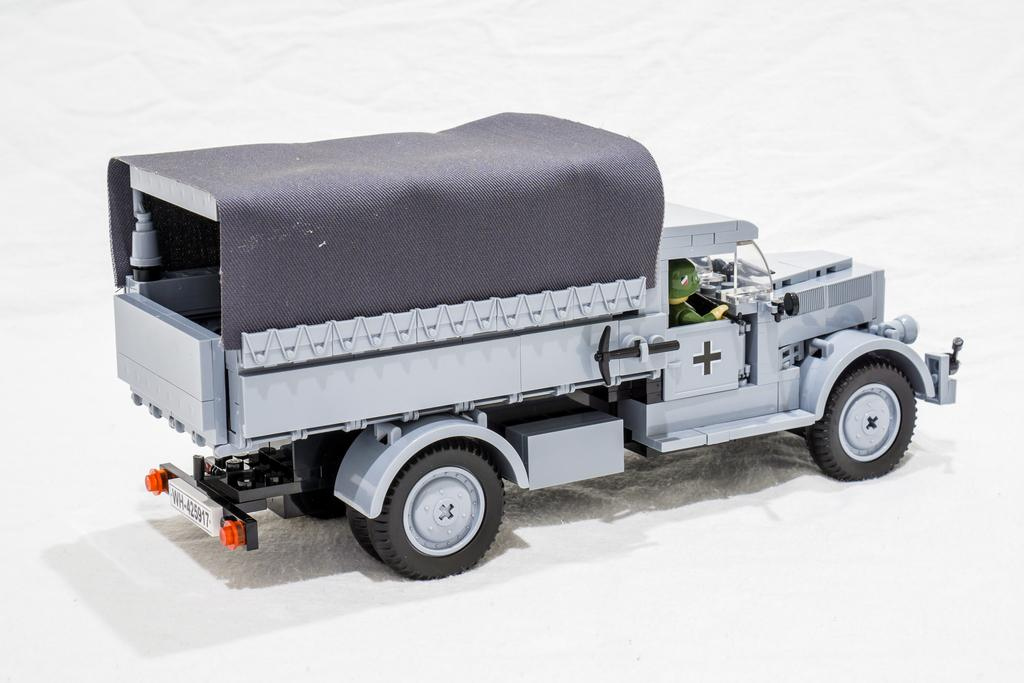What color is the floor in the image? The floor in the image is white. What is the person in the image doing? There is a person driving a vehicle in the image. What type of sweater is the person wearing while driving in the image? There is no information about a sweater or any clothing in the image, so we cannot determine what type of sweater the person might be wearing. 